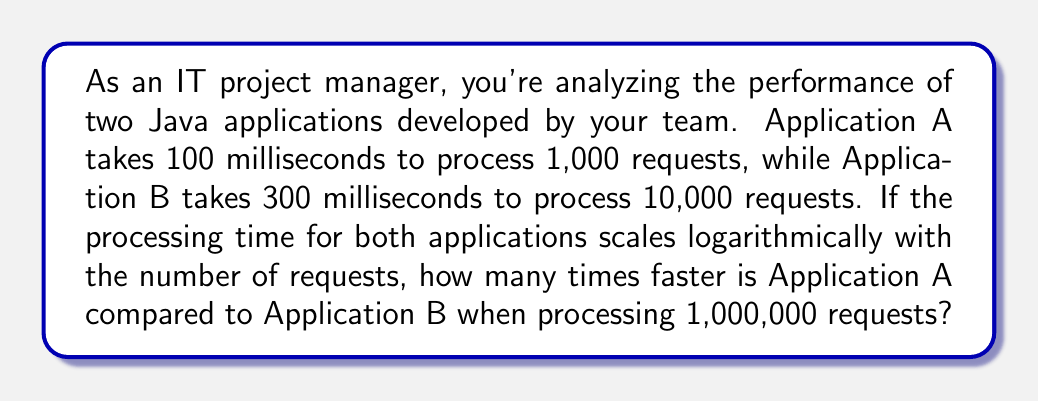Solve this math problem. Let's approach this step-by-step:

1) First, we need to understand the logarithmic scaling. If processing time $t$ scales logarithmically with the number of requests $n$, we can express this as:

   $t = k \log(n) + c$

   where $k$ and $c$ are constants specific to each application.

2) For Application A:
   $100 = k_A \log(1000) + c_A$

3) For Application B:
   $300 = k_B \log(10000) + c_B$

4) We don't have enough information to solve for $c_A$ and $c_B$, but we can assume they're negligible for large $n$. So we'll focus on finding $k_A$ and $k_B$.

5) For Application A:
   $k_A = \frac{100}{\log(1000)} \approx 33.33$

6) For Application B:
   $k_B = \frac{300}{\log(10000)} \approx 75$

7) Now, for 1,000,000 requests:

   Time for A: $t_A = 33.33 \log(1000000) \approx 200$ ms
   Time for B: $t_B = 75 \log(1000000) \approx 450$ ms

8) To find how many times faster A is compared to B:

   $\frac{t_B}{t_A} = \frac{450}{200} = 2.25$

Therefore, Application A is 2.25 times faster than Application B when processing 1,000,000 requests.
Answer: Application A is 2.25 times faster than Application B when processing 1,000,000 requests. 